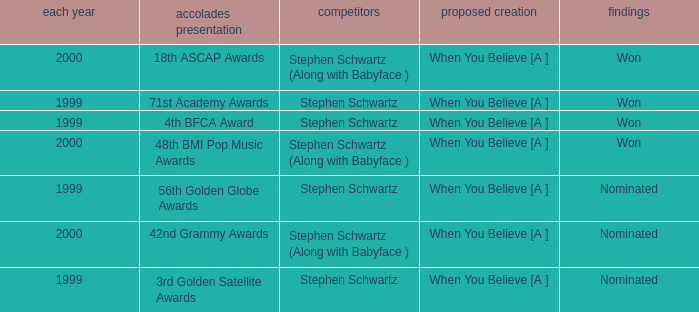Which Nominated Work won in 2000? When You Believe [A ], When You Believe [A ]. 